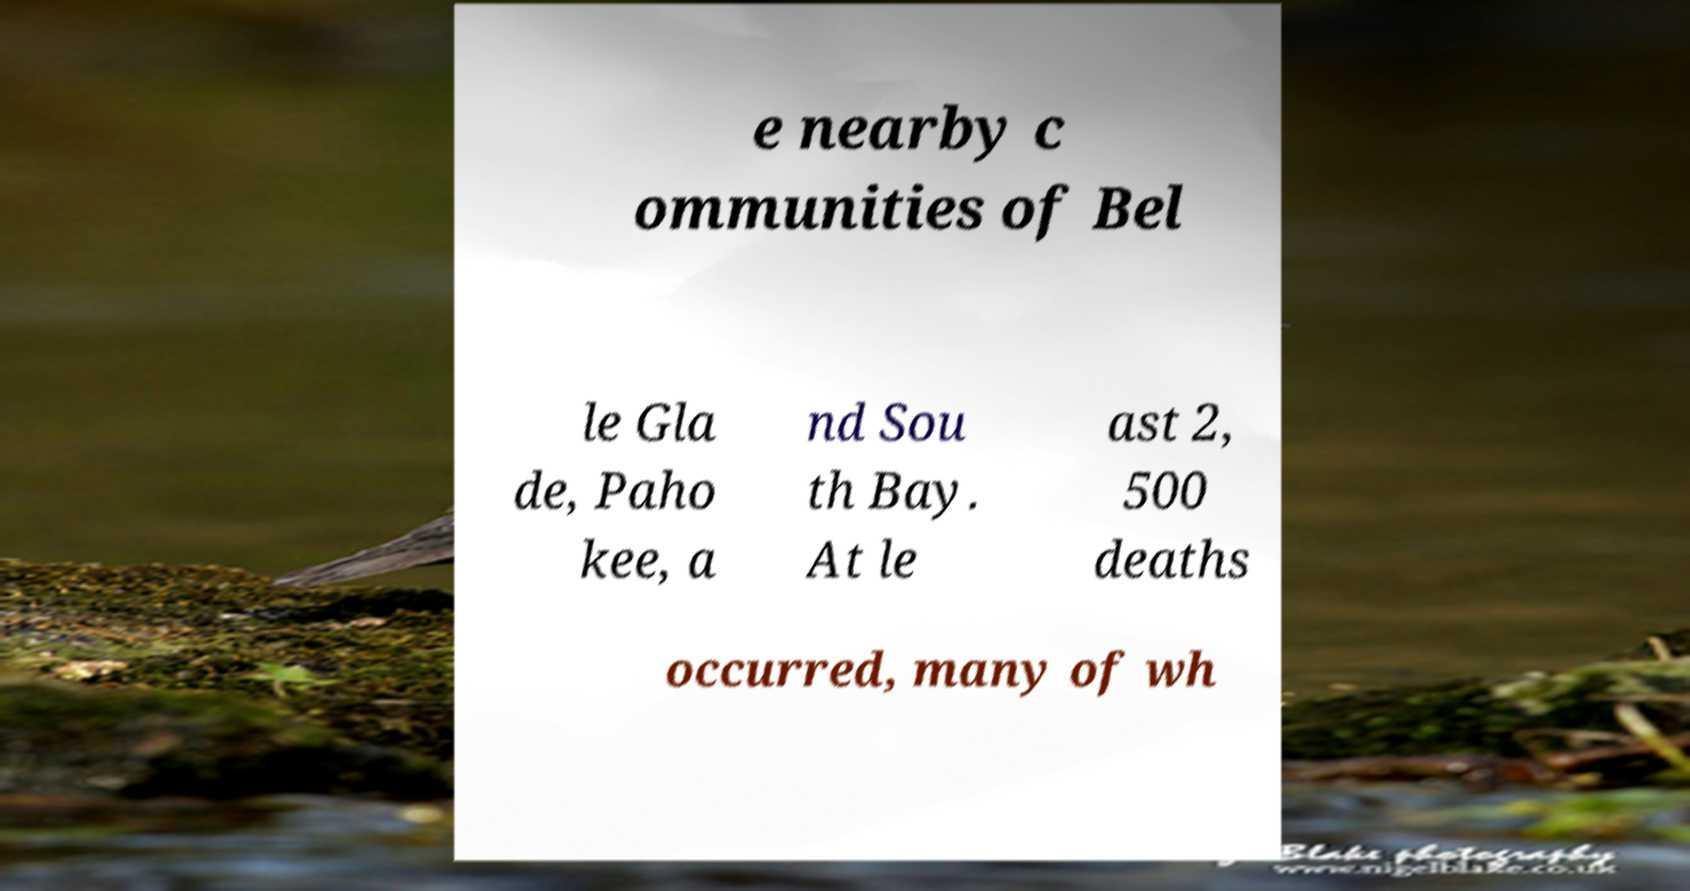Can you read and provide the text displayed in the image?This photo seems to have some interesting text. Can you extract and type it out for me? e nearby c ommunities of Bel le Gla de, Paho kee, a nd Sou th Bay. At le ast 2, 500 deaths occurred, many of wh 